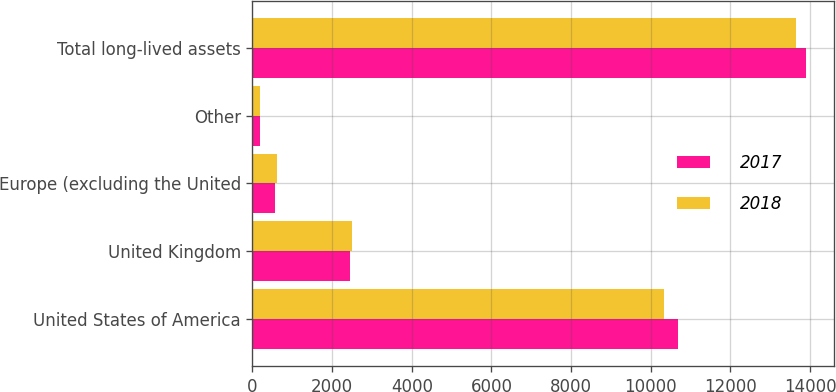Convert chart to OTSL. <chart><loc_0><loc_0><loc_500><loc_500><stacked_bar_chart><ecel><fcel>United States of America<fcel>United Kingdom<fcel>Europe (excluding the United<fcel>Other<fcel>Total long-lived assets<nl><fcel>2017<fcel>10678<fcel>2458<fcel>576<fcel>199<fcel>13911<nl><fcel>2018<fcel>10344<fcel>2502<fcel>616<fcel>180<fcel>13642<nl></chart> 